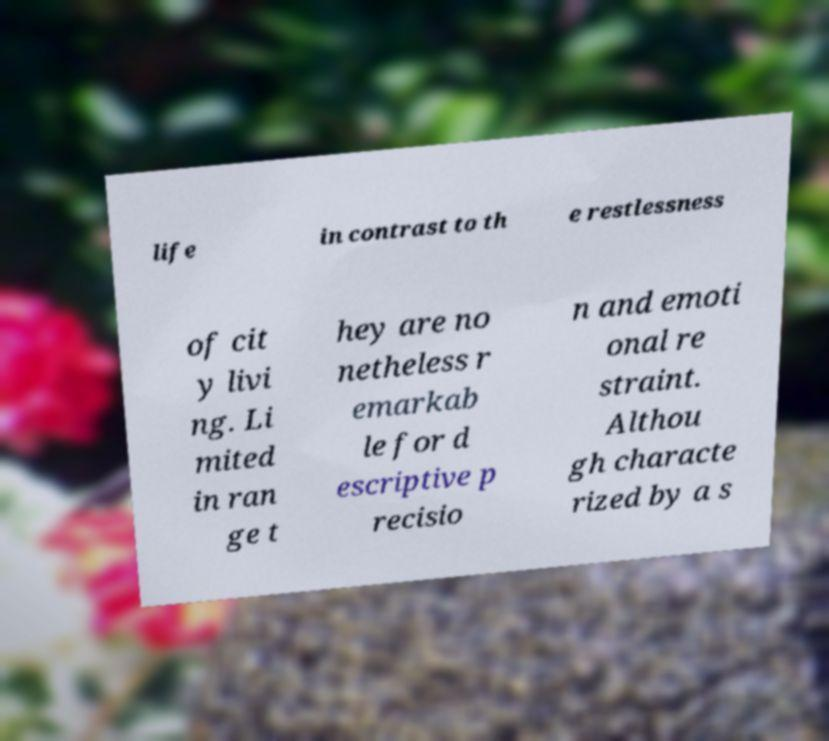Could you extract and type out the text from this image? life in contrast to th e restlessness of cit y livi ng. Li mited in ran ge t hey are no netheless r emarkab le for d escriptive p recisio n and emoti onal re straint. Althou gh characte rized by a s 